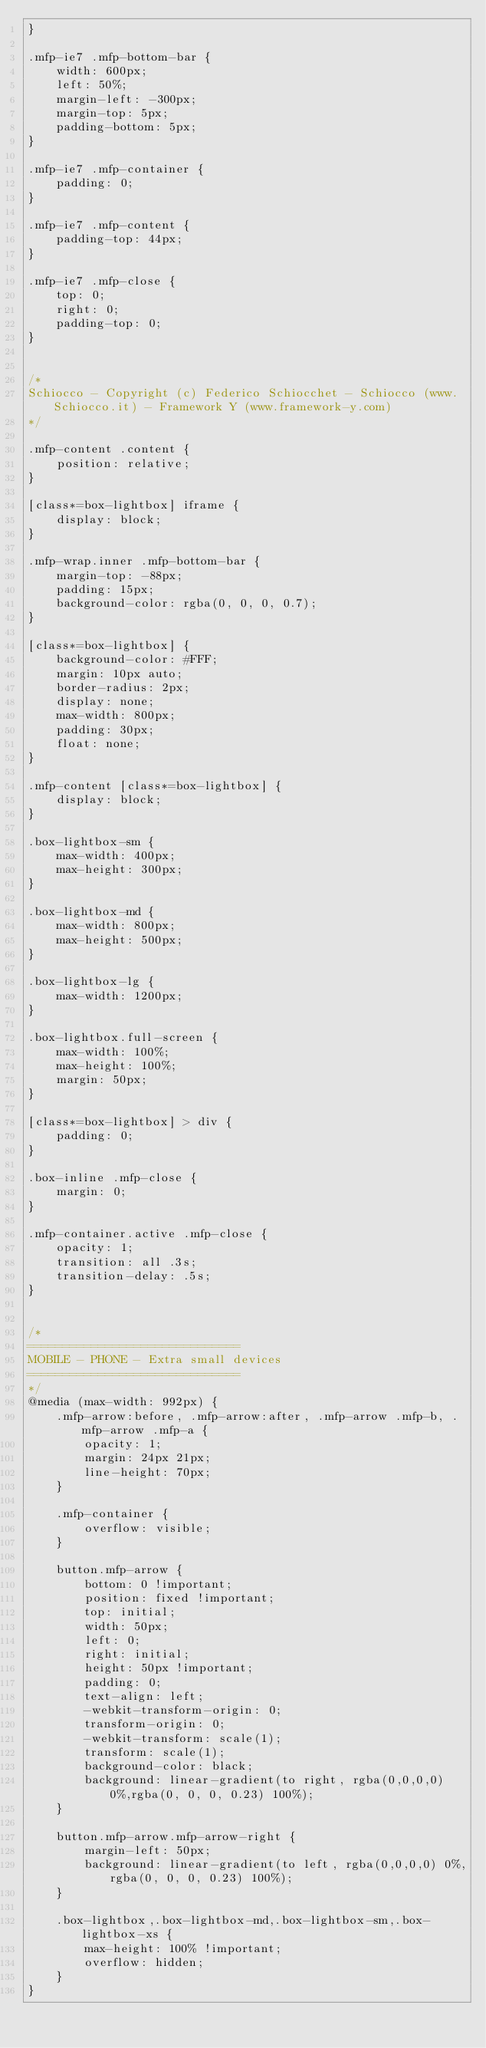Convert code to text. <code><loc_0><loc_0><loc_500><loc_500><_CSS_>}

.mfp-ie7 .mfp-bottom-bar {
    width: 600px;
    left: 50%;
    margin-left: -300px;
    margin-top: 5px;
    padding-bottom: 5px;
}

.mfp-ie7 .mfp-container {
    padding: 0;
}

.mfp-ie7 .mfp-content {
    padding-top: 44px;
}

.mfp-ie7 .mfp-close {
    top: 0;
    right: 0;
    padding-top: 0;
}


/*
Schiocco - Copyright (c) Federico Schiocchet - Schiocco (www.Schiocco.it) - Framework Y (www.framework-y.com)
*/

.mfp-content .content {
    position: relative;
}

[class*=box-lightbox] iframe {
    display: block;
}

.mfp-wrap.inner .mfp-bottom-bar {
    margin-top: -88px;
    padding: 15px;
    background-color: rgba(0, 0, 0, 0.7);
}

[class*=box-lightbox] {
    background-color: #FFF;
    margin: 10px auto;
    border-radius: 2px;
    display: none;
    max-width: 800px;
    padding: 30px;
    float: none;
}

.mfp-content [class*=box-lightbox] {
    display: block;
}

.box-lightbox-sm {
    max-width: 400px;
    max-height: 300px;
}

.box-lightbox-md {
    max-width: 800px;
    max-height: 500px;
}

.box-lightbox-lg {
    max-width: 1200px;
}

.box-lightbox.full-screen {
    max-width: 100%;
    max-height: 100%;
    margin: 50px;
}

[class*=box-lightbox] > div {
    padding: 0;
}

.box-inline .mfp-close {
    margin: 0;
}

.mfp-container.active .mfp-close {
    opacity: 1;
    transition: all .3s;
    transition-delay: .5s;
}

 
/*
==============================
MOBILE - PHONE - Extra small devices
==============================
*/
@media (max-width: 992px) {
    .mfp-arrow:before, .mfp-arrow:after, .mfp-arrow .mfp-b, .mfp-arrow .mfp-a {
        opacity: 1;
        margin: 24px 21px;
        line-height: 70px;
    }

    .mfp-container {
        overflow: visible;
    }

    button.mfp-arrow {
        bottom: 0 !important;
        position: fixed !important;
        top: initial;
        width: 50px;
        left: 0;
        right: initial;
        height: 50px !important;
        padding: 0;
        text-align: left;
        -webkit-transform-origin: 0;
        transform-origin: 0;
        -webkit-transform: scale(1);
        transform: scale(1);
        background-color: black;
        background: linear-gradient(to right, rgba(0,0,0,0) 0%,rgba(0, 0, 0, 0.23) 100%);
    }

    button.mfp-arrow.mfp-arrow-right {
        margin-left: 50px;
        background: linear-gradient(to left, rgba(0,0,0,0) 0%,rgba(0, 0, 0, 0.23) 100%);
    }

    .box-lightbox,.box-lightbox-md,.box-lightbox-sm,.box-lightbox-xs {
        max-height: 100% !important;
        overflow: hidden;
    }
}
</code> 